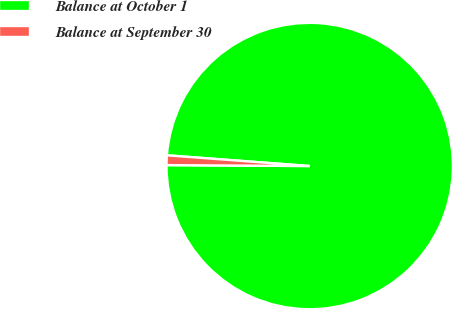Convert chart. <chart><loc_0><loc_0><loc_500><loc_500><pie_chart><fcel>Balance at October 1<fcel>Balance at September 30<nl><fcel>98.91%<fcel>1.09%<nl></chart> 